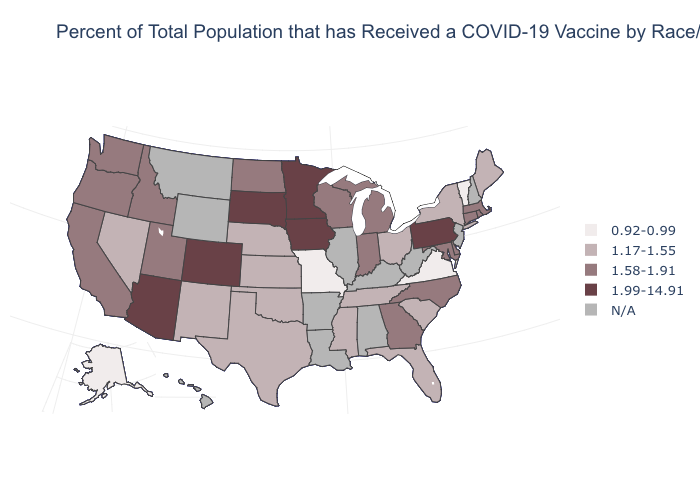Name the states that have a value in the range N/A?
Answer briefly. Alabama, Arkansas, Hawaii, Illinois, Kentucky, Louisiana, Montana, New Hampshire, New Jersey, West Virginia, Wyoming. What is the value of New Hampshire?
Write a very short answer. N/A. Name the states that have a value in the range 1.99-14.91?
Give a very brief answer. Arizona, Colorado, Iowa, Minnesota, Pennsylvania, South Dakota. What is the lowest value in the MidWest?
Keep it brief. 0.92-0.99. What is the lowest value in the USA?
Concise answer only. 0.92-0.99. Name the states that have a value in the range 1.58-1.91?
Answer briefly. California, Connecticut, Delaware, Georgia, Idaho, Indiana, Maryland, Massachusetts, Michigan, North Carolina, North Dakota, Oregon, Rhode Island, Utah, Washington, Wisconsin. Name the states that have a value in the range 1.17-1.55?
Answer briefly. Florida, Kansas, Maine, Mississippi, Nebraska, Nevada, New Mexico, New York, Ohio, Oklahoma, South Carolina, Tennessee, Texas. Does Pennsylvania have the highest value in the Northeast?
Keep it brief. Yes. Name the states that have a value in the range 0.92-0.99?
Quick response, please. Alaska, Missouri, Vermont, Virginia. What is the value of Missouri?
Answer briefly. 0.92-0.99. What is the value of Mississippi?
Quick response, please. 1.17-1.55. Name the states that have a value in the range N/A?
Short answer required. Alabama, Arkansas, Hawaii, Illinois, Kentucky, Louisiana, Montana, New Hampshire, New Jersey, West Virginia, Wyoming. Is the legend a continuous bar?
Give a very brief answer. No. Does Vermont have the lowest value in the Northeast?
Short answer required. Yes. 